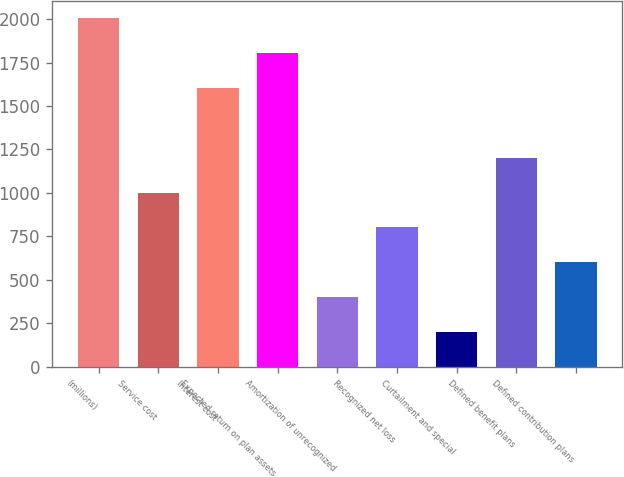Convert chart. <chart><loc_0><loc_0><loc_500><loc_500><bar_chart><fcel>(millions)<fcel>Service cost<fcel>Interest cost<fcel>Expected return on plan assets<fcel>Amortization of unrecognized<fcel>Recognized net loss<fcel>Curtailment and special<fcel>Defined benefit plans<fcel>Defined contribution plans<nl><fcel>2005<fcel>1002.65<fcel>1604.06<fcel>1804.53<fcel>401.24<fcel>802.18<fcel>200.77<fcel>1203.12<fcel>601.71<nl></chart> 